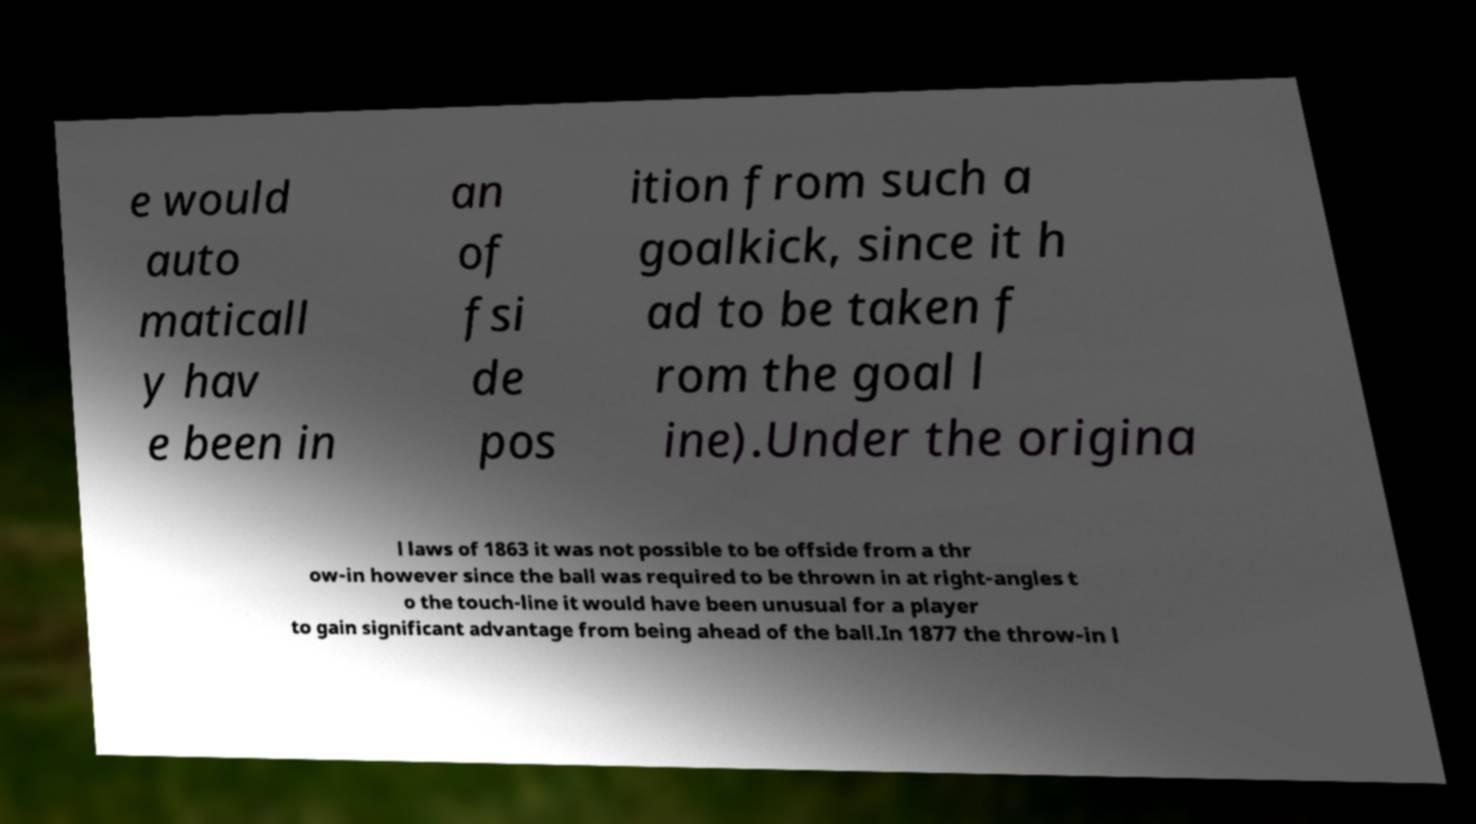Could you assist in decoding the text presented in this image and type it out clearly? e would auto maticall y hav e been in an of fsi de pos ition from such a goalkick, since it h ad to be taken f rom the goal l ine).Under the origina l laws of 1863 it was not possible to be offside from a thr ow-in however since the ball was required to be thrown in at right-angles t o the touch-line it would have been unusual for a player to gain significant advantage from being ahead of the ball.In 1877 the throw-in l 